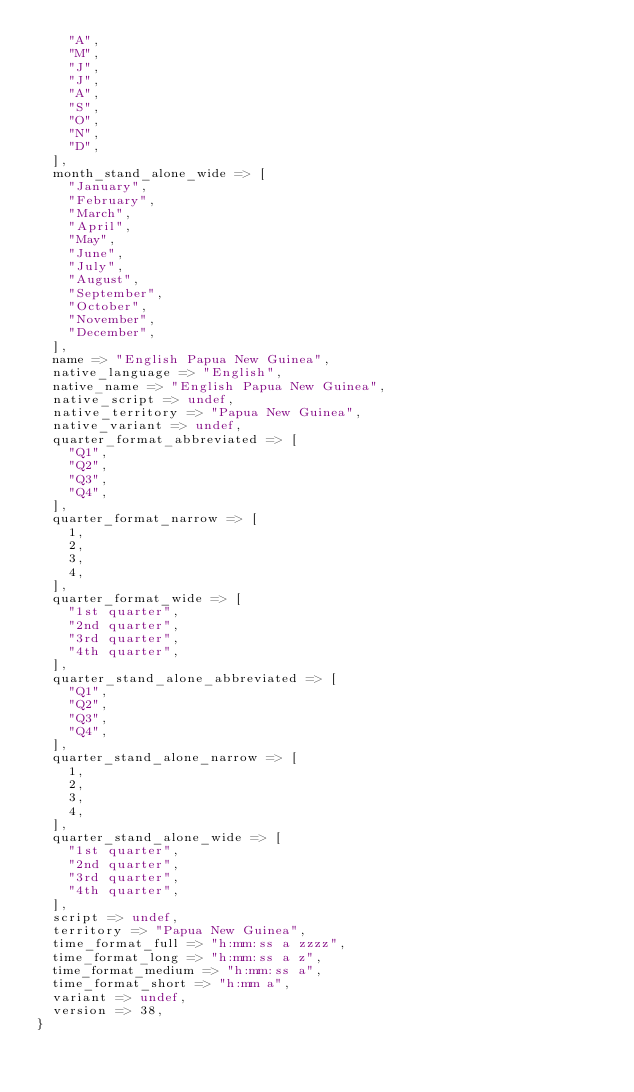<code> <loc_0><loc_0><loc_500><loc_500><_Perl_>    "A",
    "M",
    "J",
    "J",
    "A",
    "S",
    "O",
    "N",
    "D",
  ],
  month_stand_alone_wide => [
    "January",
    "February",
    "March",
    "April",
    "May",
    "June",
    "July",
    "August",
    "September",
    "October",
    "November",
    "December",
  ],
  name => "English Papua New Guinea",
  native_language => "English",
  native_name => "English Papua New Guinea",
  native_script => undef,
  native_territory => "Papua New Guinea",
  native_variant => undef,
  quarter_format_abbreviated => [
    "Q1",
    "Q2",
    "Q3",
    "Q4",
  ],
  quarter_format_narrow => [
    1,
    2,
    3,
    4,
  ],
  quarter_format_wide => [
    "1st quarter",
    "2nd quarter",
    "3rd quarter",
    "4th quarter",
  ],
  quarter_stand_alone_abbreviated => [
    "Q1",
    "Q2",
    "Q3",
    "Q4",
  ],
  quarter_stand_alone_narrow => [
    1,
    2,
    3,
    4,
  ],
  quarter_stand_alone_wide => [
    "1st quarter",
    "2nd quarter",
    "3rd quarter",
    "4th quarter",
  ],
  script => undef,
  territory => "Papua New Guinea",
  time_format_full => "h:mm:ss a zzzz",
  time_format_long => "h:mm:ss a z",
  time_format_medium => "h:mm:ss a",
  time_format_short => "h:mm a",
  variant => undef,
  version => 38,
}
</code> 